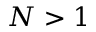<formula> <loc_0><loc_0><loc_500><loc_500>N > 1</formula> 